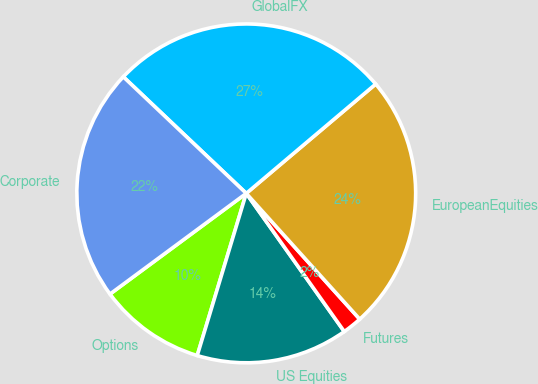Convert chart. <chart><loc_0><loc_0><loc_500><loc_500><pie_chart><fcel>Options<fcel>US Equities<fcel>Futures<fcel>EuropeanEquities<fcel>GlobalFX<fcel>Corporate<nl><fcel>10.2%<fcel>14.49%<fcel>1.86%<fcel>24.48%<fcel>26.76%<fcel>22.2%<nl></chart> 